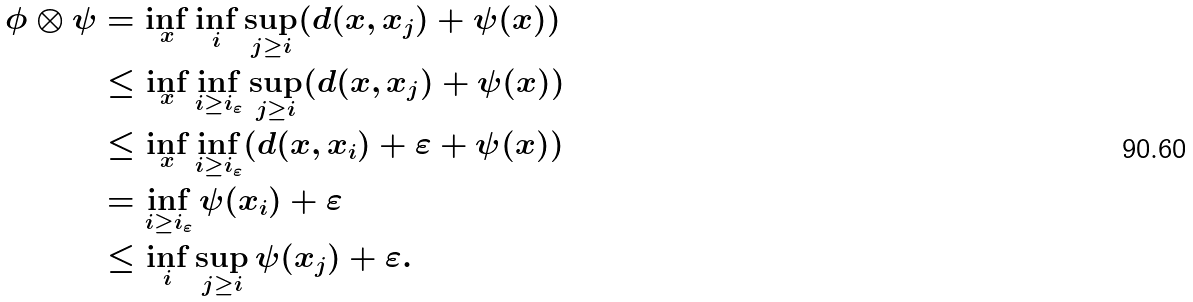Convert formula to latex. <formula><loc_0><loc_0><loc_500><loc_500>\phi \otimes \psi & = \inf _ { x } \inf _ { i } \sup _ { j \geq i } ( d ( x , x _ { j } ) + \psi ( x ) ) \\ & \leq \inf _ { x } \inf _ { i \geq i _ { \varepsilon } } \sup _ { j \geq i } ( d ( x , x _ { j } ) + \psi ( x ) ) \\ & \leq \inf _ { x } \inf _ { i \geq i _ { \varepsilon } } ( d ( x , x _ { i } ) + \varepsilon + \psi ( x ) ) \\ & = \inf _ { i \geq i _ { \varepsilon } } \psi ( x _ { i } ) + \varepsilon \\ & \leq \inf _ { i } \sup _ { j \geq i } \psi ( x _ { j } ) + \varepsilon .</formula> 